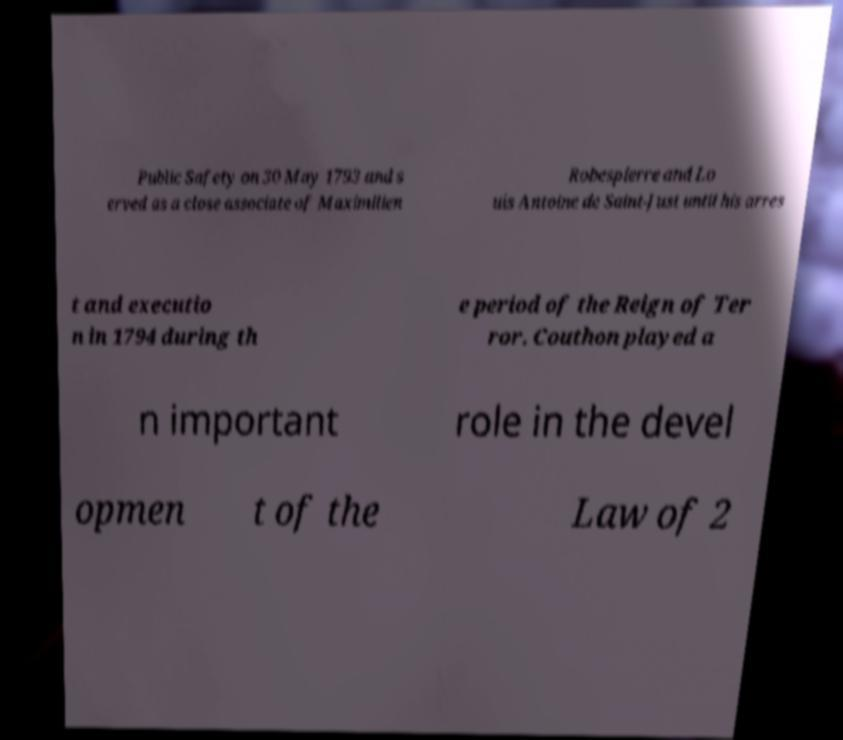What messages or text are displayed in this image? I need them in a readable, typed format. Public Safety on 30 May 1793 and s erved as a close associate of Maximilien Robespierre and Lo uis Antoine de Saint-Just until his arres t and executio n in 1794 during th e period of the Reign of Ter ror. Couthon played a n important role in the devel opmen t of the Law of 2 